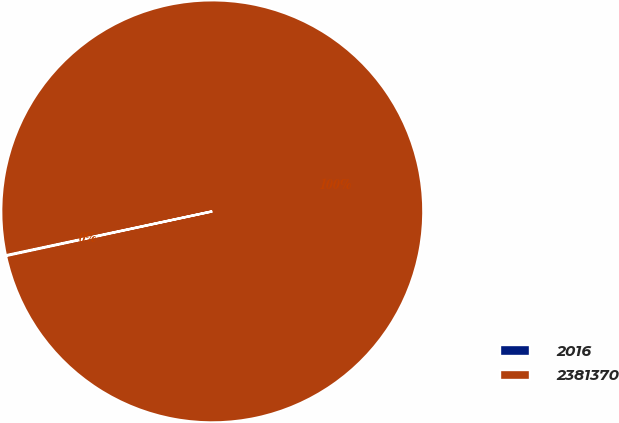Convert chart to OTSL. <chart><loc_0><loc_0><loc_500><loc_500><pie_chart><fcel>2016<fcel>2381370<nl><fcel>0.05%<fcel>99.95%<nl></chart> 